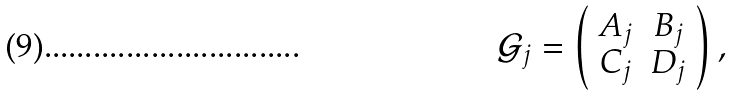Convert formula to latex. <formula><loc_0><loc_0><loc_500><loc_500>\mathcal { G } _ { j } = \left ( \begin{array} { c c } A _ { j } & B _ { j } \\ C _ { j } & D _ { j } \end{array} \right ) ,</formula> 